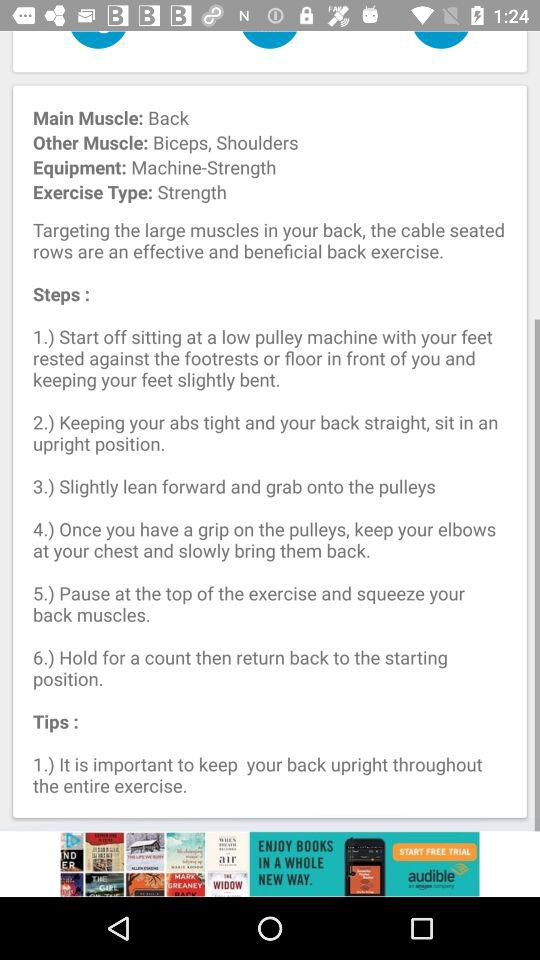How many exercise steps are there?
Answer the question using a single word or phrase. 6 